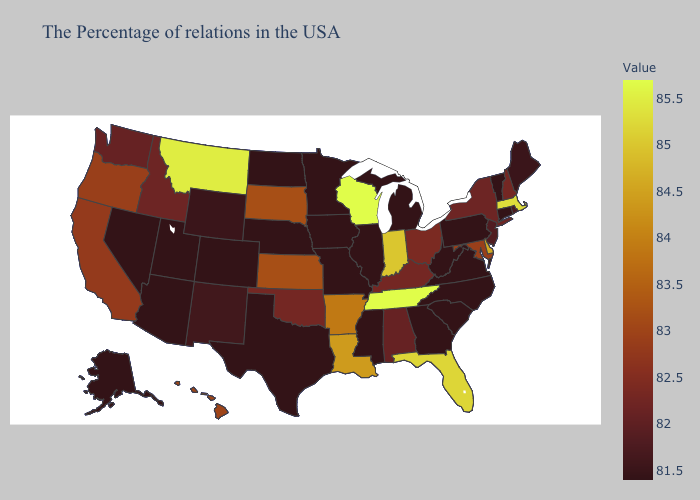Does New Hampshire have the lowest value in the Northeast?
Keep it brief. No. Among the states that border Montana , does North Dakota have the highest value?
Be succinct. No. Among the states that border Illinois , which have the highest value?
Short answer required. Wisconsin. Is the legend a continuous bar?
Quick response, please. Yes. Does Tennessee have the highest value in the USA?
Keep it brief. Yes. 